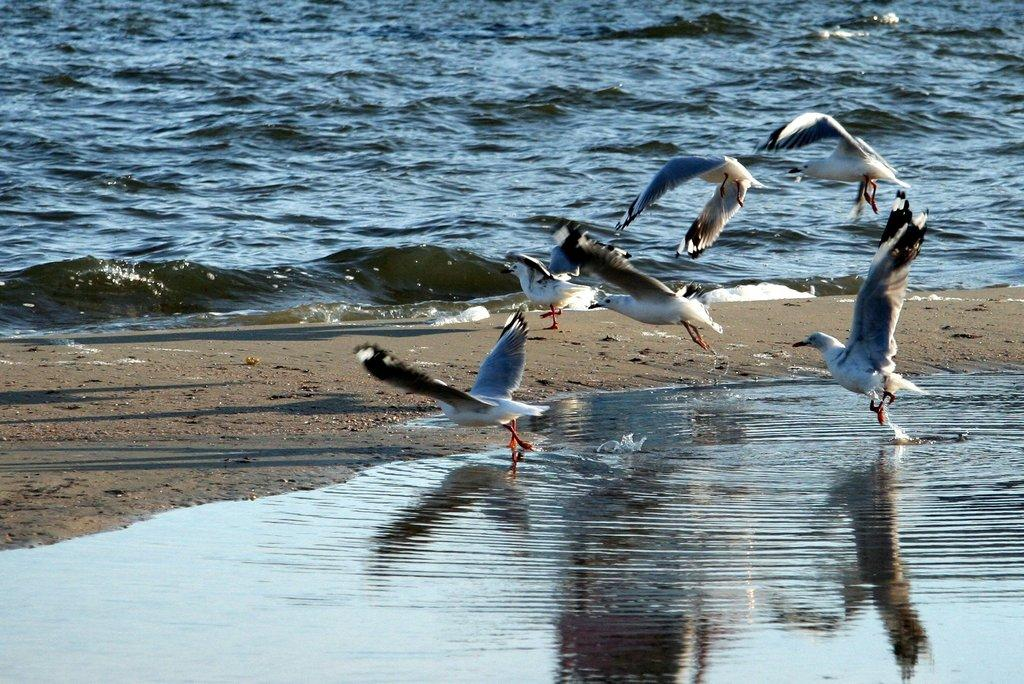What type of animals can be seen in the image? There is a group of birds in the image. What is visible in the background of the image? There is water visible in the background of the image. What type of band is playing in the background of the image? There is no band present in the image; it features a group of birds and water in the background. 